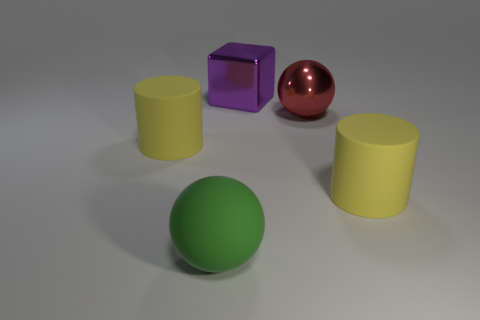Add 4 yellow rubber cylinders. How many objects exist? 9 Subtract 1 balls. How many balls are left? 1 Subtract all large cylinders. Subtract all big matte cylinders. How many objects are left? 1 Add 2 big yellow matte objects. How many big yellow matte objects are left? 4 Add 1 big purple objects. How many big purple objects exist? 2 Subtract 0 red blocks. How many objects are left? 5 Subtract all cubes. How many objects are left? 4 Subtract all blue cylinders. Subtract all blue cubes. How many cylinders are left? 2 Subtract all cyan balls. How many green cylinders are left? 0 